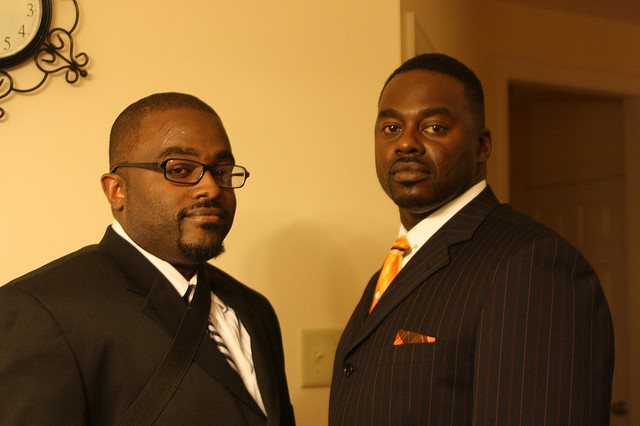<image>What organization does he work for? It's unknown what organization he works for. He could work for a church, a bank like Wells Fargo, or a business such as Hilton. What organization does he work for? I don't know what organization he works for. It could be any of the mentioned options. 